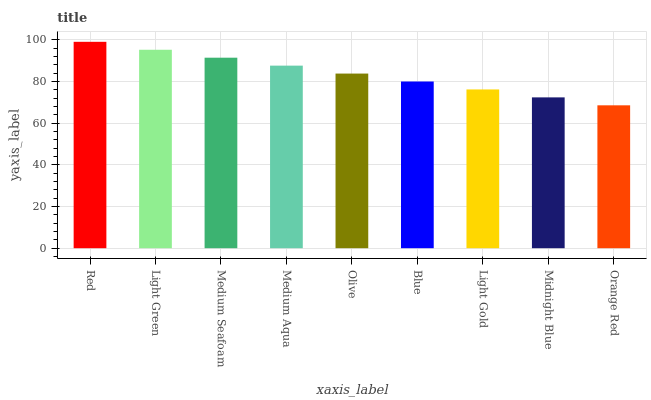Is Orange Red the minimum?
Answer yes or no. Yes. Is Red the maximum?
Answer yes or no. Yes. Is Light Green the minimum?
Answer yes or no. No. Is Light Green the maximum?
Answer yes or no. No. Is Red greater than Light Green?
Answer yes or no. Yes. Is Light Green less than Red?
Answer yes or no. Yes. Is Light Green greater than Red?
Answer yes or no. No. Is Red less than Light Green?
Answer yes or no. No. Is Olive the high median?
Answer yes or no. Yes. Is Olive the low median?
Answer yes or no. Yes. Is Medium Aqua the high median?
Answer yes or no. No. Is Light Green the low median?
Answer yes or no. No. 